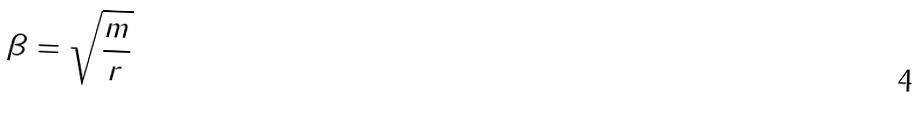Convert formula to latex. <formula><loc_0><loc_0><loc_500><loc_500>\beta = \sqrt { \frac { m } { r } }</formula> 